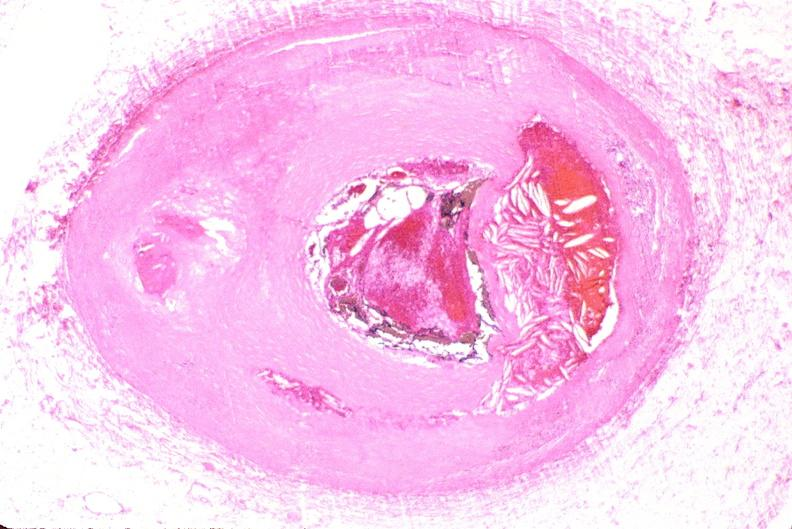s very good example present?
Answer the question using a single word or phrase. No 